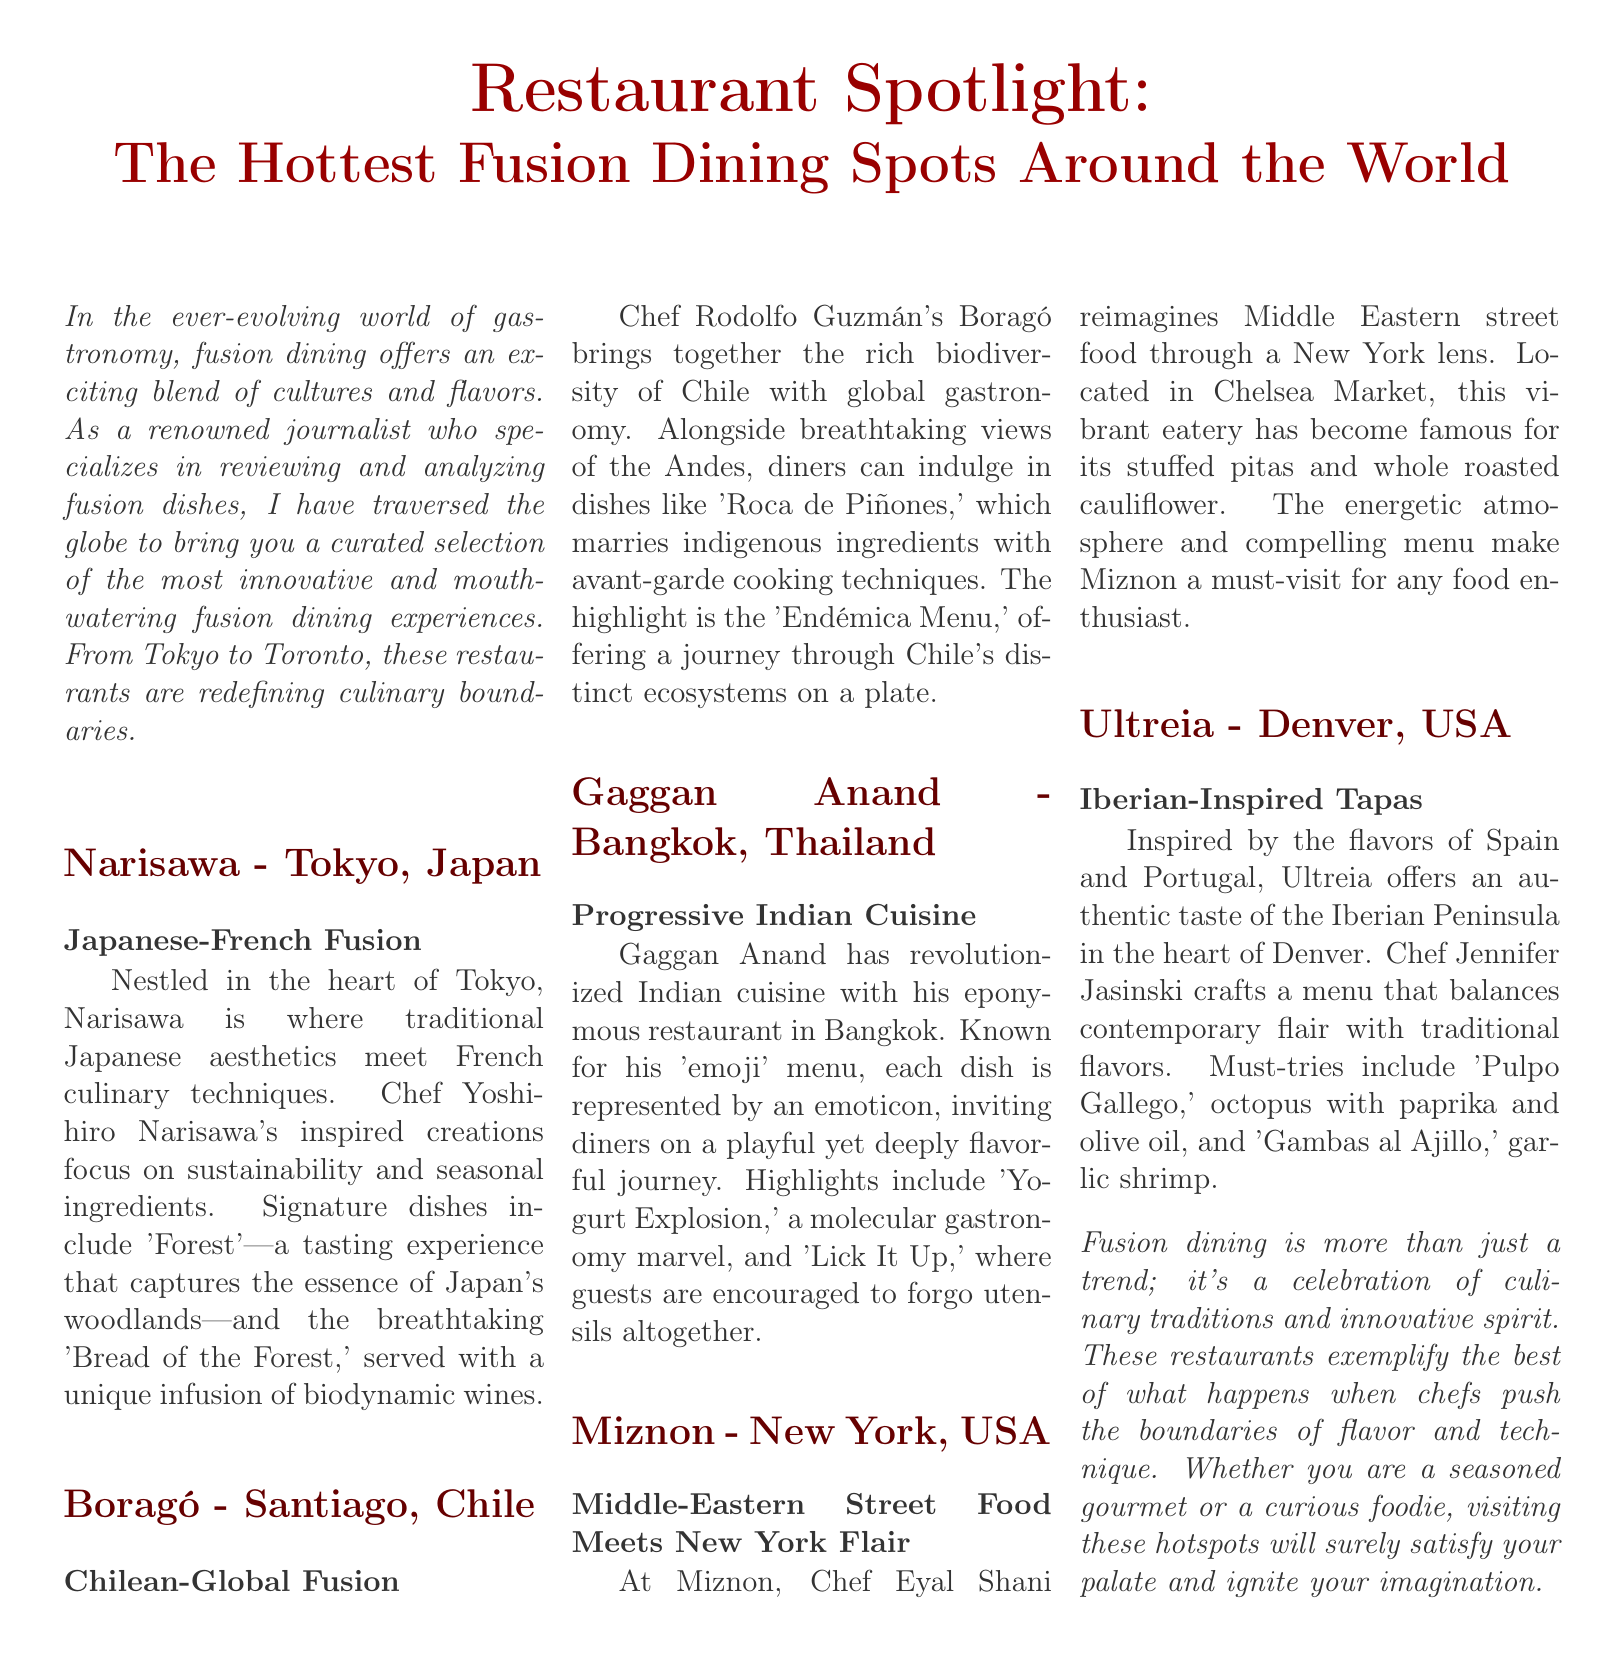What is the name of the restaurant in Tokyo? The document mentions Narisawa as the restaurant located in Tokyo.
Answer: Narisawa What type of cuisine does Boragó focus on? The document states that Boragó specializes in Chilean-Global Fusion cuisine.
Answer: Chilean-Global Fusion Who is the chef at Gaggan Anand? According to the document, the chef at Gaggan Anand is Gaggan Anand himself.
Answer: Gaggan Anand What is a signature dish at Miznon? The document lists stuffed pitas as a well-known item on the Miznon menu.
Answer: Stuffed pitas What is the dining style at Gaggan Anand? The document describes the dining experience at Gaggan Anand as a playful journey with an 'emoji' menu.
Answer: 'Emoji' menu Which city is Ultreia located in? The document specifies that Ultreia is situated in Denver.
Answer: Denver What primary ingredient is used in 'Pulpo Gallego'? The document states that octopus is the primary ingredient in the dish 'Pulpo Gallego.'
Answer: Octopus How does Miznon reinterpret its culinary roots? The document explains that Miznon reimagines Middle Eastern street food through a New York lens.
Answer: New York lens What culinary focus is emphasized at Narisawa? The document mentions that Narisawa emphasizes sustainability and seasonal ingredients in its cuisine.
Answer: Sustainability and seasonal ingredients 